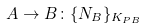Convert formula to latex. <formula><loc_0><loc_0><loc_500><loc_500>A \rightarrow B \colon \{ N _ { B } \} _ { K _ { P B } }</formula> 